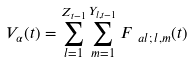Convert formula to latex. <formula><loc_0><loc_0><loc_500><loc_500>V _ { \alpha } ( t ) = \sum _ { l = 1 } ^ { Z _ { t - 1 } } \sum _ { m = 1 } ^ { Y _ { l , t - 1 } } F _ { \ a l ; \, l , m } ( t )</formula> 